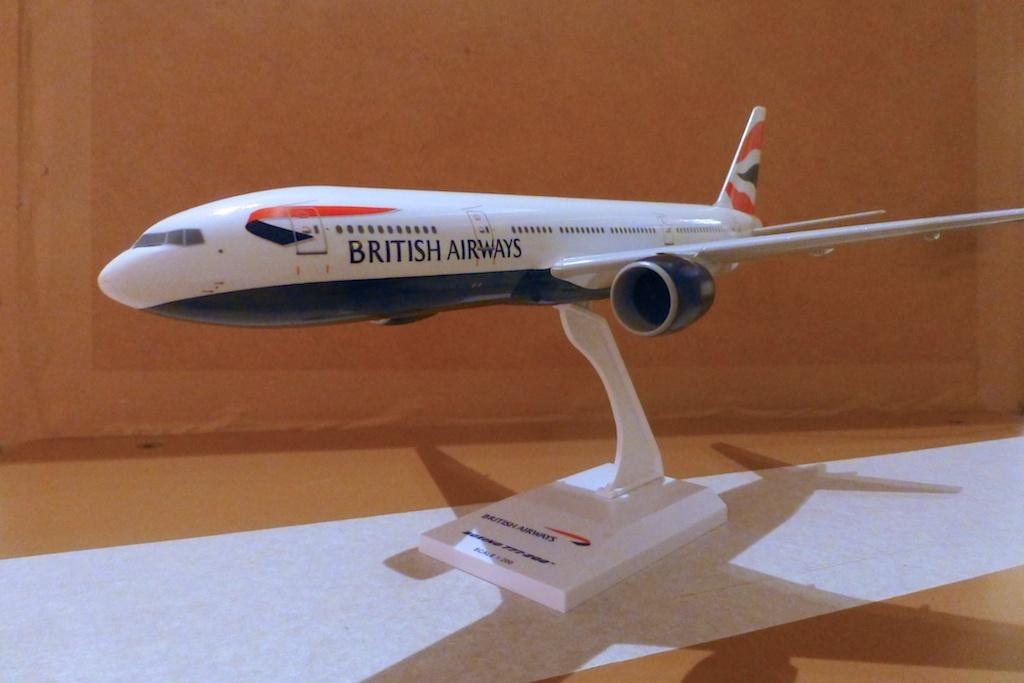<image>
Give a short and clear explanation of the subsequent image. A white model plane, with the text British Airways, sits on a desk. 